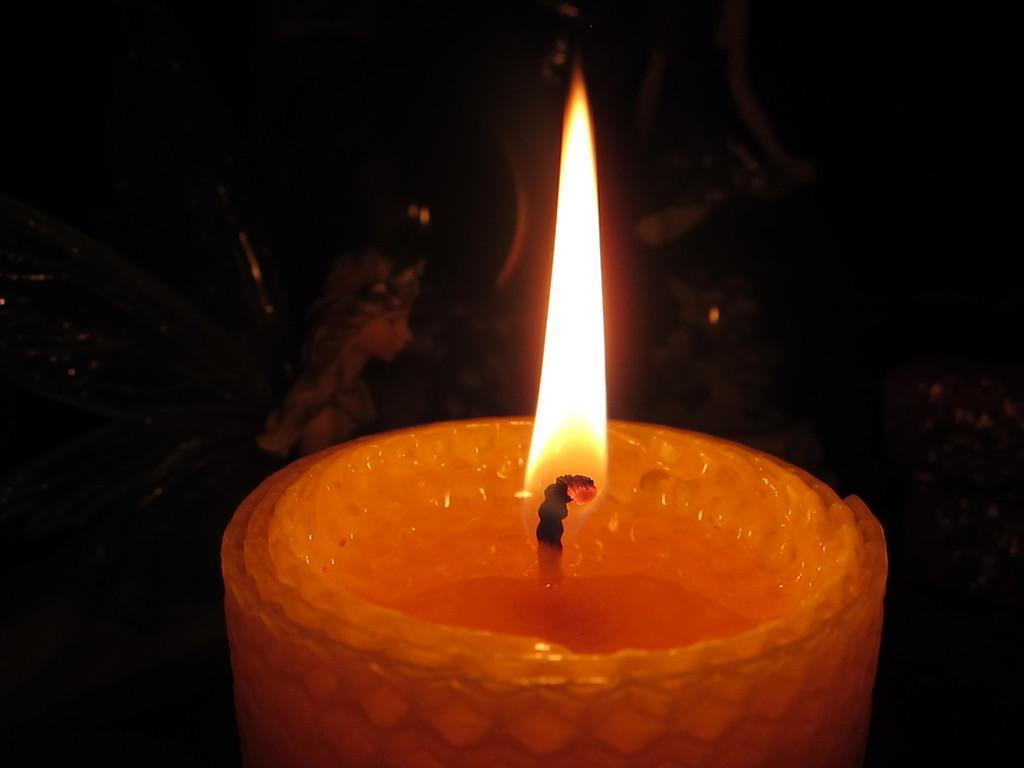How would you summarize this image in a sentence or two? In this image, we can see a candle and there is a doll, there is a dark background. 